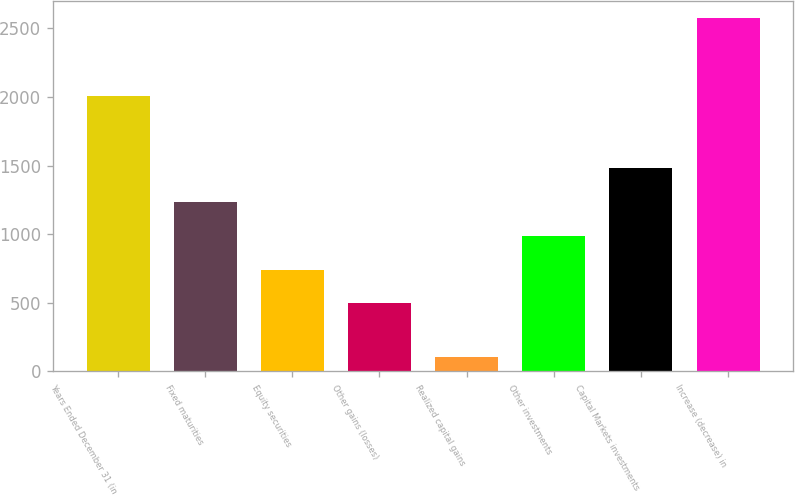Convert chart to OTSL. <chart><loc_0><loc_0><loc_500><loc_500><bar_chart><fcel>Years Ended December 31 (in<fcel>Fixed maturities<fcel>Equity securities<fcel>Other gains (losses)<fcel>Realized capital gains<fcel>Other investments<fcel>Capital Markets investments<fcel>Increase (decrease) in<nl><fcel>2006<fcel>1236.4<fcel>742.8<fcel>496<fcel>106<fcel>989.6<fcel>1483.2<fcel>2574<nl></chart> 